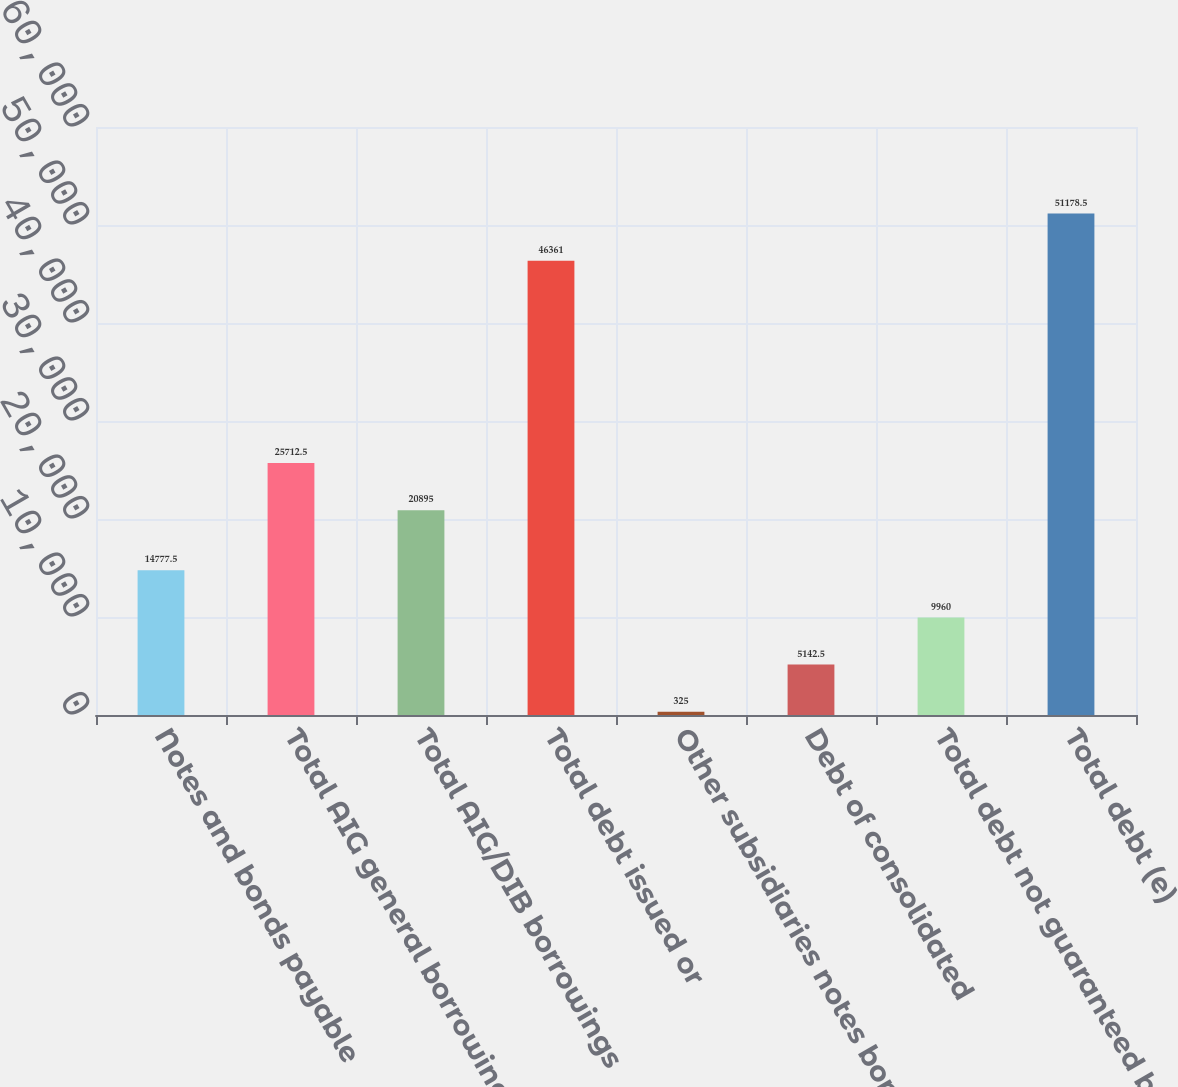<chart> <loc_0><loc_0><loc_500><loc_500><bar_chart><fcel>Notes and bonds payable<fcel>Total AIG general borrowings<fcel>Total AIG/DIB borrowings<fcel>Total debt issued or<fcel>Other subsidiaries notes bonds<fcel>Debt of consolidated<fcel>Total debt not guaranteed by<fcel>Total debt (e)<nl><fcel>14777.5<fcel>25712.5<fcel>20895<fcel>46361<fcel>325<fcel>5142.5<fcel>9960<fcel>51178.5<nl></chart> 